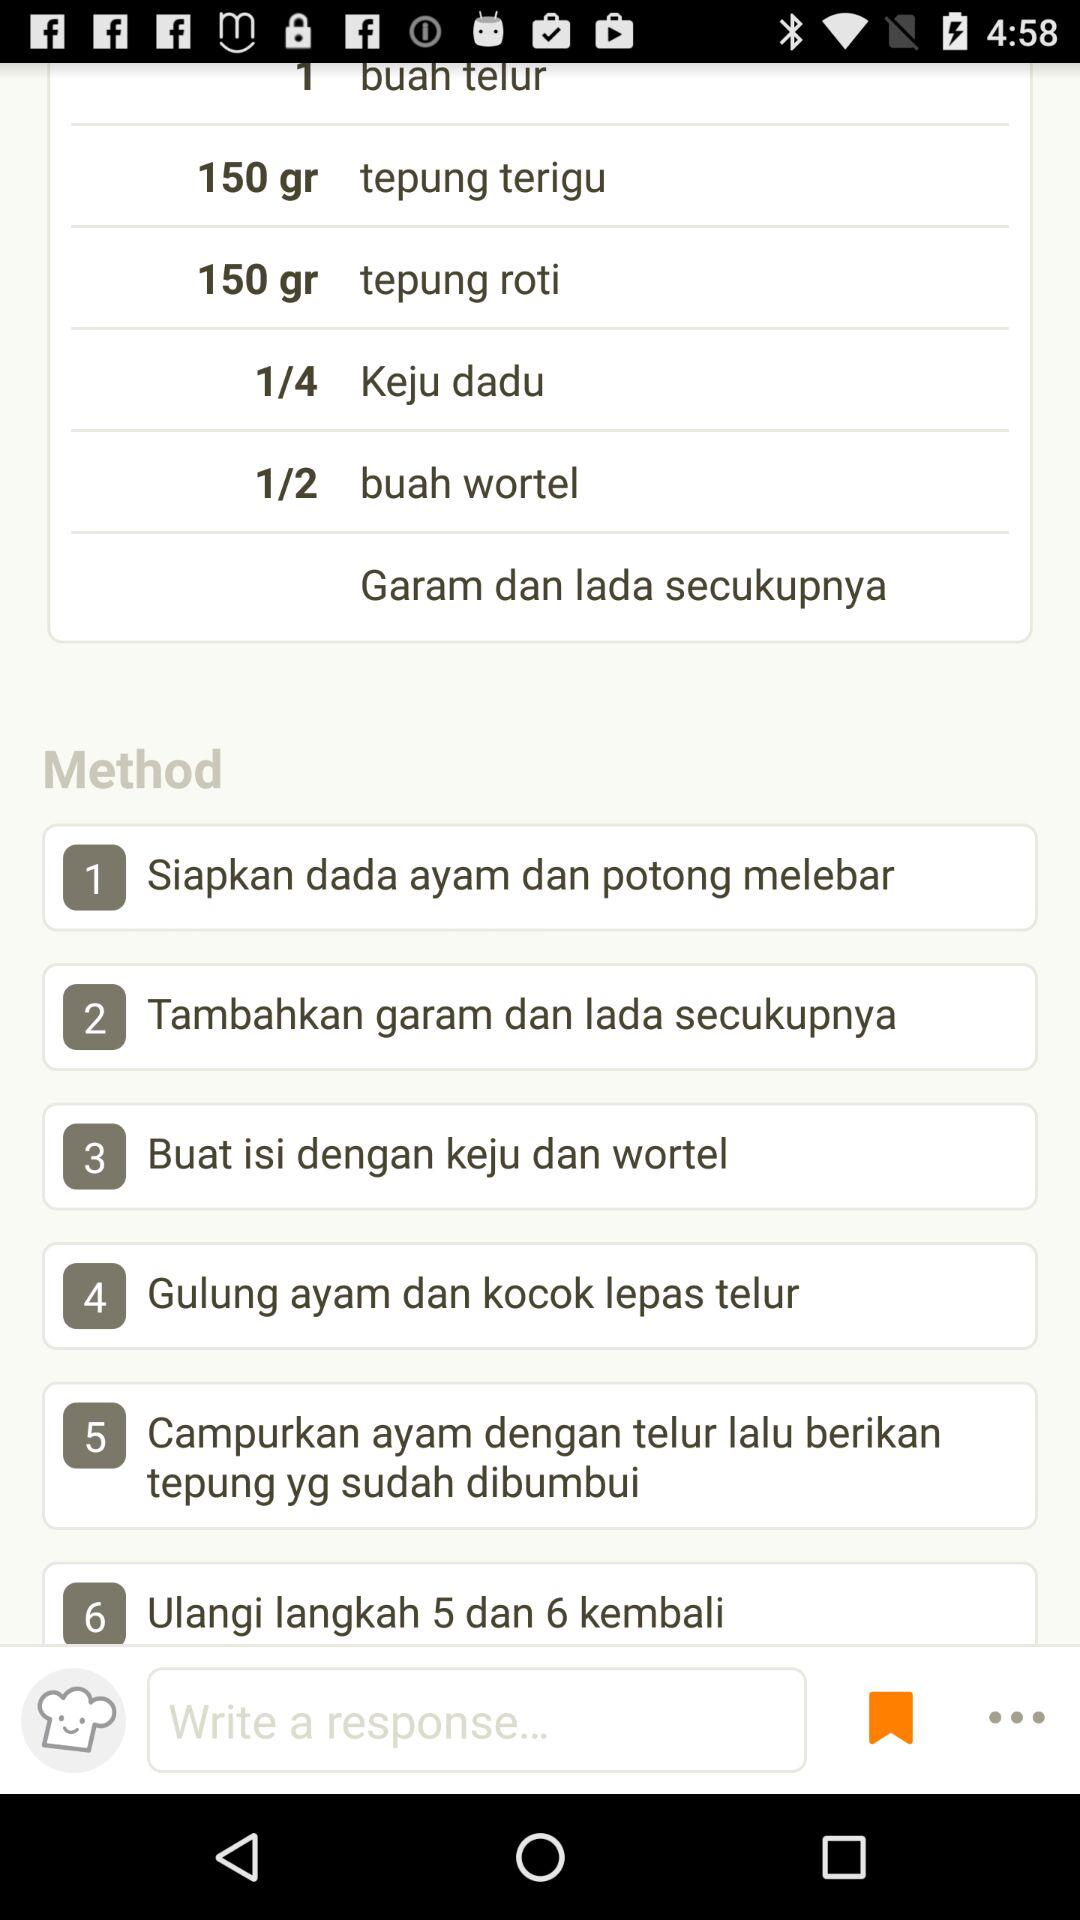How many steps are there in the recipe?
Answer the question using a single word or phrase. 6 